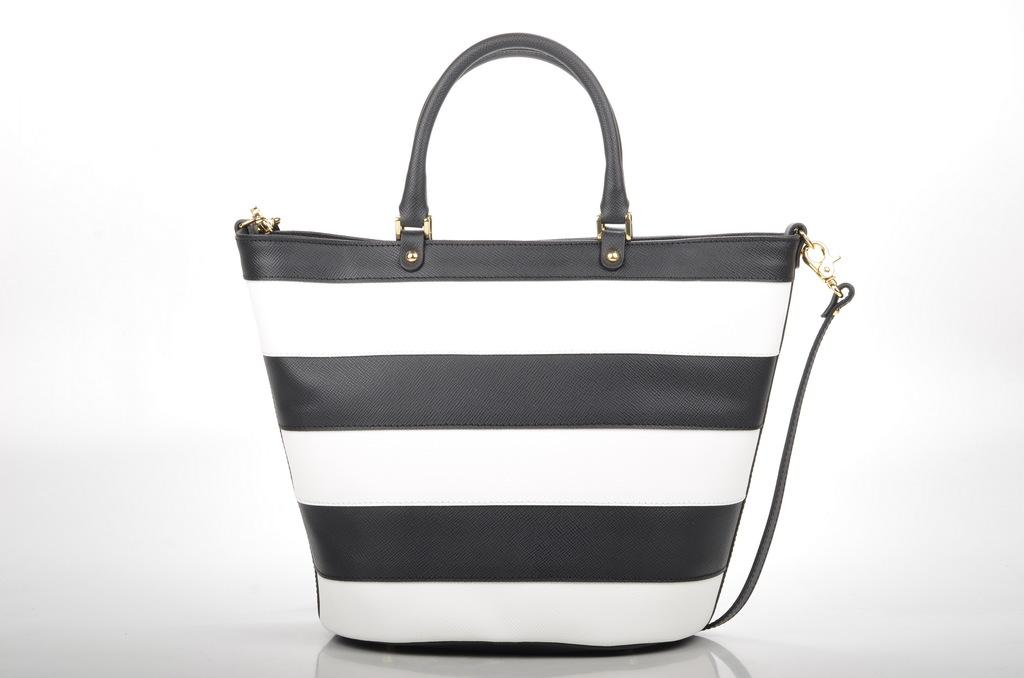What type of handbag is visible in the image? There is a black and white handbag in the image. What color is the background of the image? The background of the image is white in color. What type of education is being offered at the border in the image? There is no border or educational institution present in the image. 